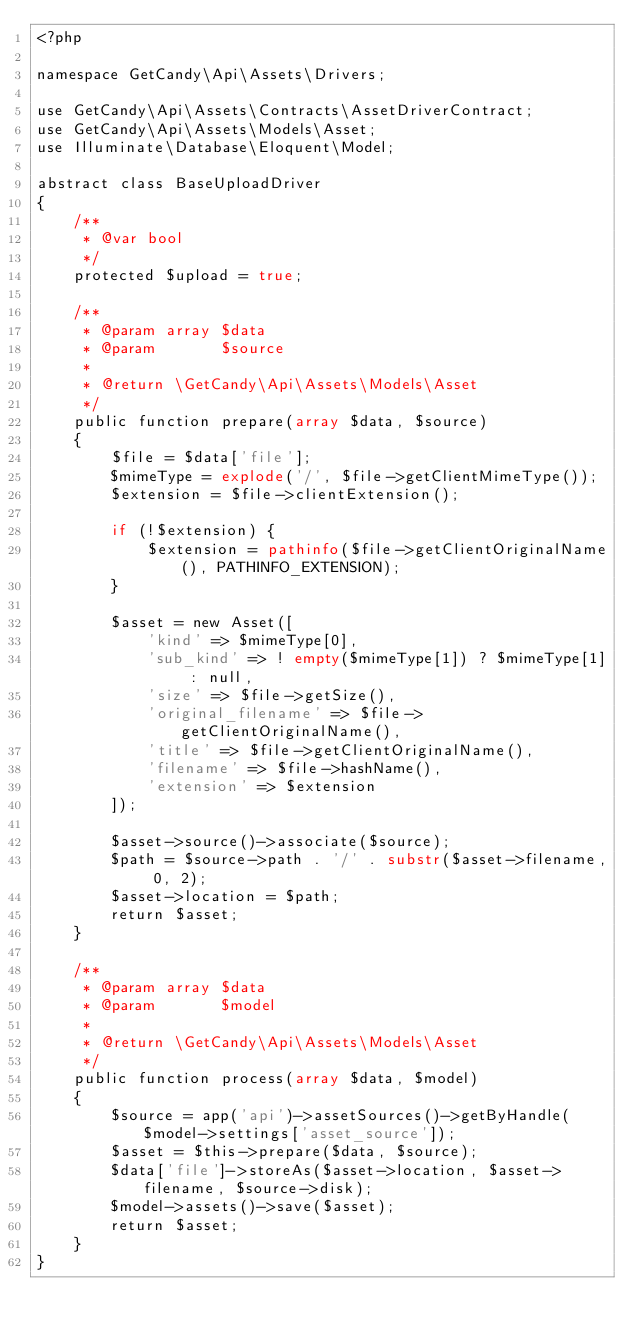<code> <loc_0><loc_0><loc_500><loc_500><_PHP_><?php

namespace GetCandy\Api\Assets\Drivers;

use GetCandy\Api\Assets\Contracts\AssetDriverContract;
use GetCandy\Api\Assets\Models\Asset;
use Illuminate\Database\Eloquent\Model;

abstract class BaseUploadDriver
{
    /**
     * @var bool
     */
    protected $upload = true;

    /**
     * @param array $data
     * @param       $source
     *
     * @return \GetCandy\Api\Assets\Models\Asset
     */
    public function prepare(array $data, $source)
    {
        $file = $data['file'];
        $mimeType = explode('/', $file->getClientMimeType());
        $extension = $file->clientExtension();

        if (!$extension) {
            $extension = pathinfo($file->getClientOriginalName(), PATHINFO_EXTENSION);
        }

        $asset = new Asset([
            'kind' => $mimeType[0],
            'sub_kind' => ! empty($mimeType[1]) ? $mimeType[1] : null,
            'size' => $file->getSize(),
            'original_filename' => $file->getClientOriginalName(),
            'title' => $file->getClientOriginalName(),
            'filename' => $file->hashName(),
            'extension' => $extension
        ]);

        $asset->source()->associate($source);
        $path = $source->path . '/' . substr($asset->filename, 0, 2);
        $asset->location = $path;
        return $asset;
    }

    /**
     * @param array $data
     * @param       $model
     *
     * @return \GetCandy\Api\Assets\Models\Asset
     */
    public function process(array $data, $model)
    {
        $source = app('api')->assetSources()->getByHandle($model->settings['asset_source']);
        $asset = $this->prepare($data, $source);
        $data['file']->storeAs($asset->location, $asset->filename, $source->disk);
        $model->assets()->save($asset);
        return $asset;
    }
}
</code> 